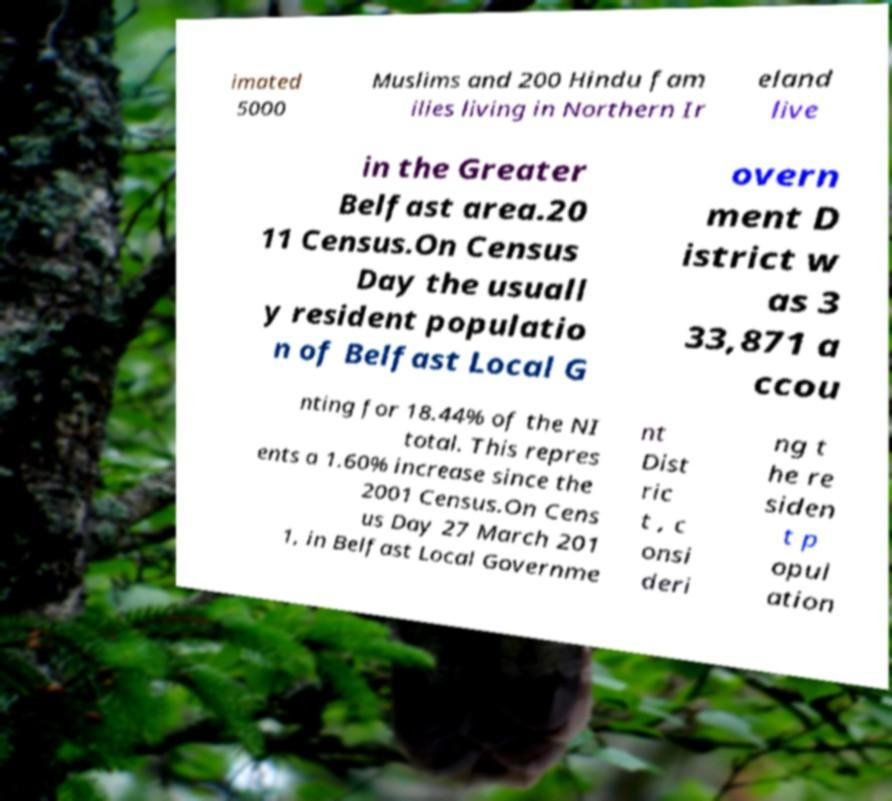There's text embedded in this image that I need extracted. Can you transcribe it verbatim? imated 5000 Muslims and 200 Hindu fam ilies living in Northern Ir eland live in the Greater Belfast area.20 11 Census.On Census Day the usuall y resident populatio n of Belfast Local G overn ment D istrict w as 3 33,871 a ccou nting for 18.44% of the NI total. This repres ents a 1.60% increase since the 2001 Census.On Cens us Day 27 March 201 1, in Belfast Local Governme nt Dist ric t , c onsi deri ng t he re siden t p opul ation 